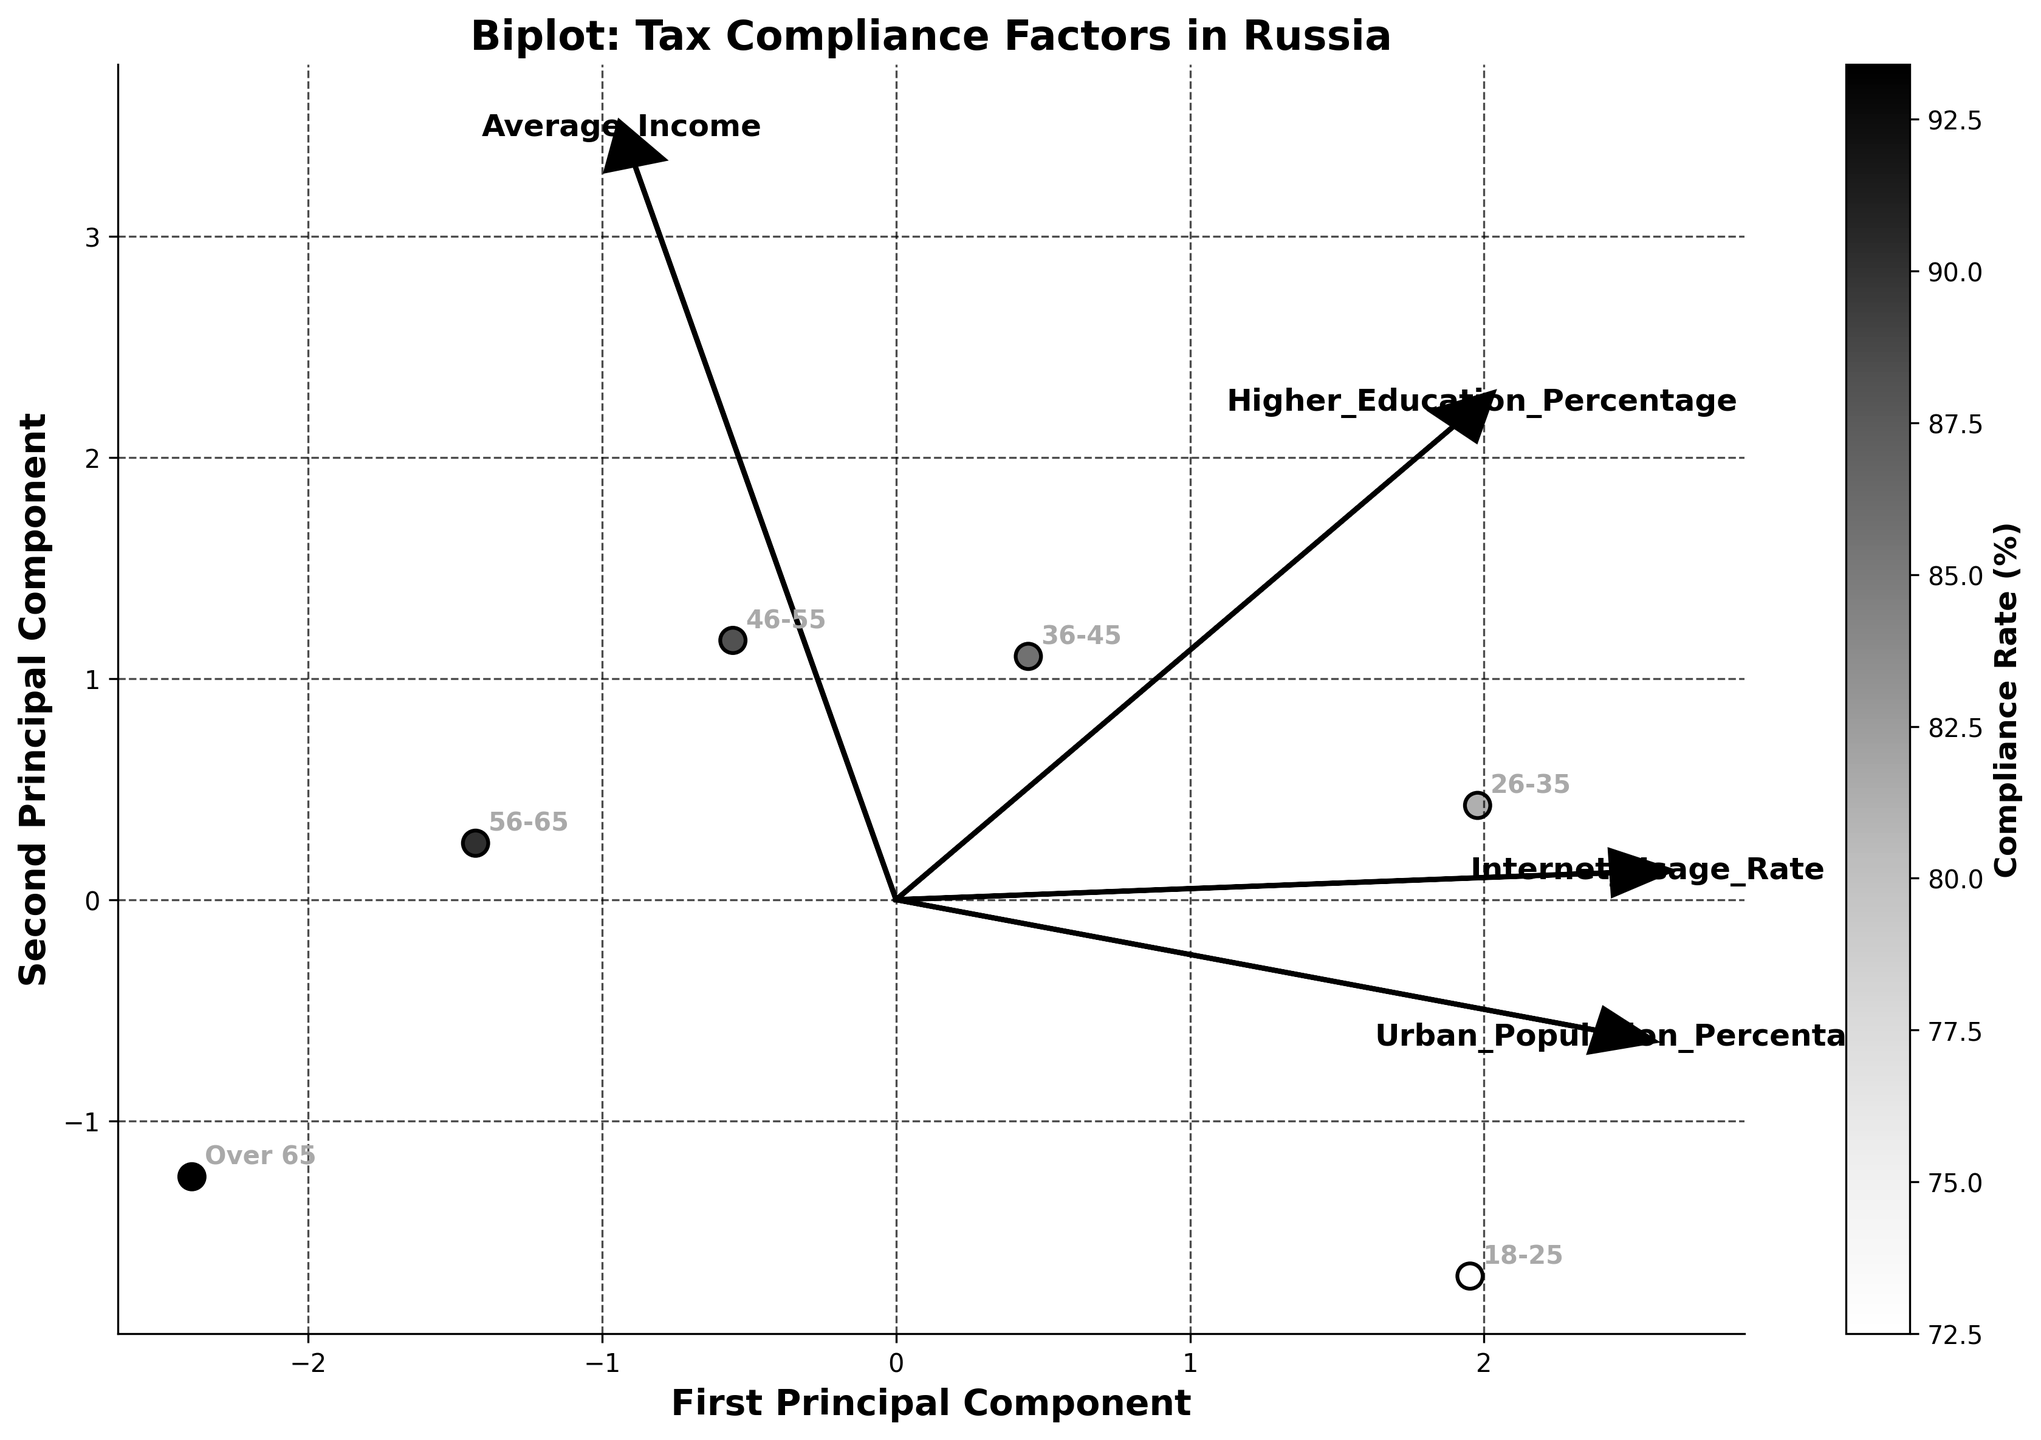What is the highest tax compliance rate among the age groups? The highest tax compliance rate can be found by looking at the colorbar and identifying the darkest point on the scatter plot. The corresponding age group annotation provides the compliance rate.
Answer: Over 65, 93.4% What is the title of the biplot? The title of the biplot is located at the top center of the plot.
Answer: Biplot: Tax Compliance Factors in Russia Which principal component explains the most variance in the data? The principal component that explains the most variance is the one labeled as 'First Principal Component' on the x-axis.
Answer: First Principal Component Compare the tax compliance rates between the '18-25' and '26-35' age groups. Which is higher? By comparing the scatter points with annotations '18-25' and '26-35', we refer to the colors closer to the colorbar scales. The '26-35' color appears darker, indicating a higher compliance rate.
Answer: 26-35 is higher Which feature has the strongest influence on the first principal component based on the arrow lengths? The feature with the longest arrow pointing towards the first principal component (x-axis) exerts the strongest influence. Observe the vector arrows and compare their lengths.
Answer: Average_Income How are 'Higher_Education_Percentage' and 'Internet_Usage_Rate' aligned in terms of their influence on the components? By examining the direction of the arrows for 'Higher_Education_Percentage' and 'Internet_Usage_Rate', they can be seen pointing in directions that indicate their relationships with the principal components.
Answer: Both align closely Identify the '46-55' age group on the plot. What is the primary factor affecting its tax compliance rate? Locate the point labeled '46-55' on the scatter plot and observe the arrows pointing towards or near it. The largest arrow in its vicinity indicates the primary factor.
Answer: Higher_Education_Percentage What percentage does the 'Urban_Population_Percentage' arrow suggest? By looking at where the 'Urban_Population_Percentage' arrow ends, we see its relation along the first and second principal component axes, reflecting its percentage.
Answer: Approximately 61% Which age group is more likely to have a higher tax compliance rate, those with higher average incomes or those with higher internet usage rates? By comparing the clustering of data points with annotations for both higher average incomes and higher internet usage rates along the principal components, we notice the predominant attribute.
Answer: Higher average incomes Is 'Internet_Usage_Rate' positively or negatively correlated with tax compliance rate based on the biplot? By examining the direction of the 'Internet_Usage_Rate' vector relative to the spread of points with higher compliance rates (darker colors), we can deduce the correlation.
Answer: Positively correlated 